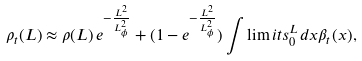Convert formula to latex. <formula><loc_0><loc_0><loc_500><loc_500>\rho _ { t } ( L ) \approx \rho ( L ) \, e ^ { - \frac { L ^ { 2 } } { L _ { \phi } ^ { 2 } } } + ( 1 - e ^ { - \frac { L ^ { 2 } } { L _ { \phi } ^ { 2 } } } ) \int \lim i t s _ { 0 } ^ { L } d x \beta _ { t } ( x ) ,</formula> 